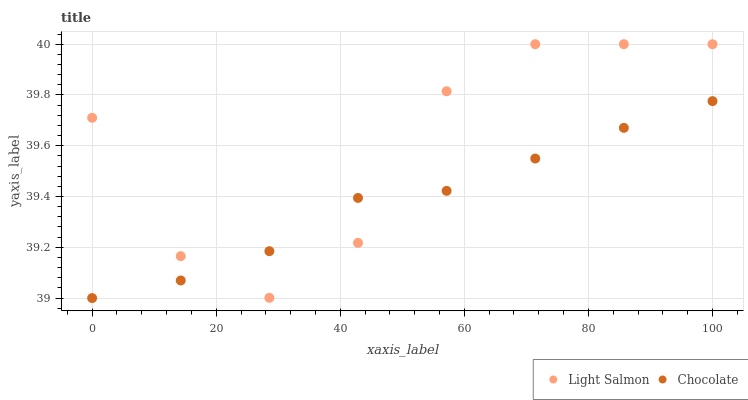Does Chocolate have the minimum area under the curve?
Answer yes or no. Yes. Does Light Salmon have the maximum area under the curve?
Answer yes or no. Yes. Does Chocolate have the maximum area under the curve?
Answer yes or no. No. Is Chocolate the smoothest?
Answer yes or no. Yes. Is Light Salmon the roughest?
Answer yes or no. Yes. Is Chocolate the roughest?
Answer yes or no. No. Does Chocolate have the lowest value?
Answer yes or no. Yes. Does Light Salmon have the highest value?
Answer yes or no. Yes. Does Chocolate have the highest value?
Answer yes or no. No. Does Light Salmon intersect Chocolate?
Answer yes or no. Yes. Is Light Salmon less than Chocolate?
Answer yes or no. No. Is Light Salmon greater than Chocolate?
Answer yes or no. No. 